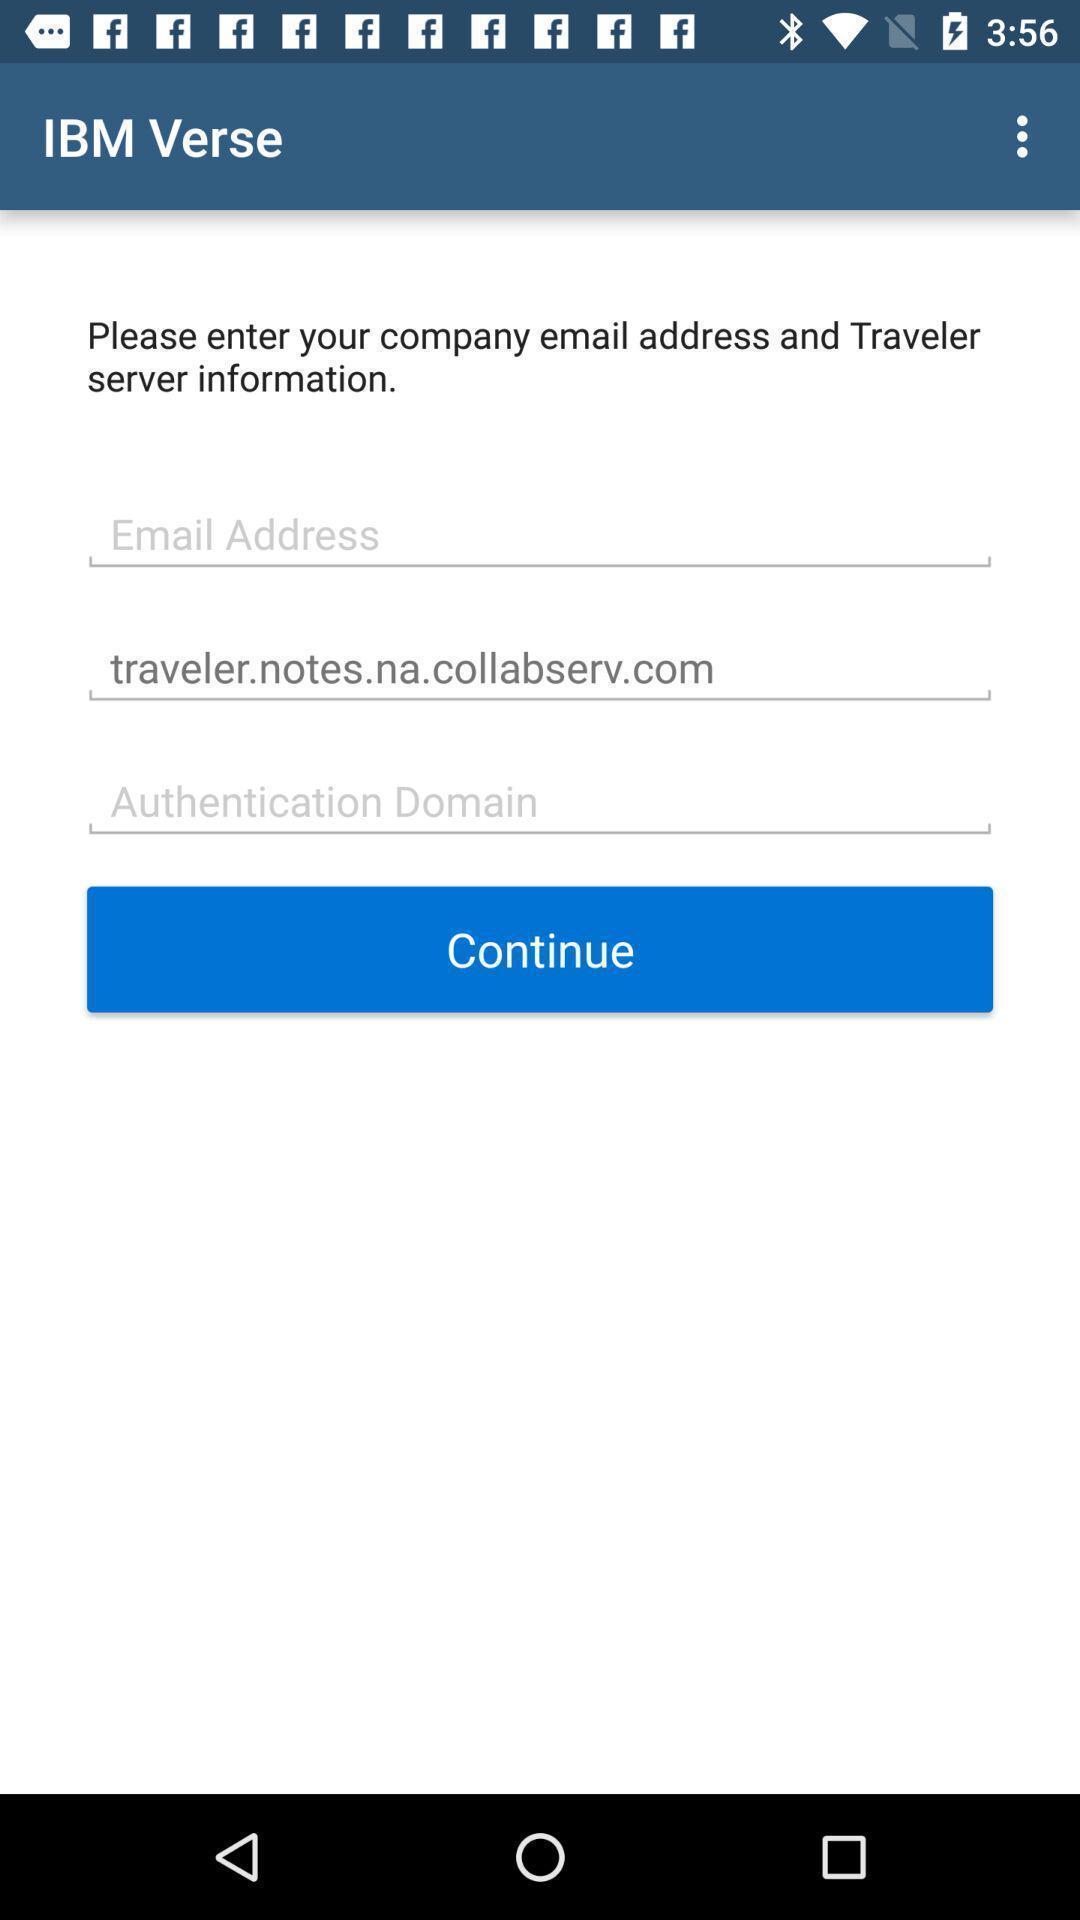Provide a description of this screenshot. Page for entering company details of a travel services app. 